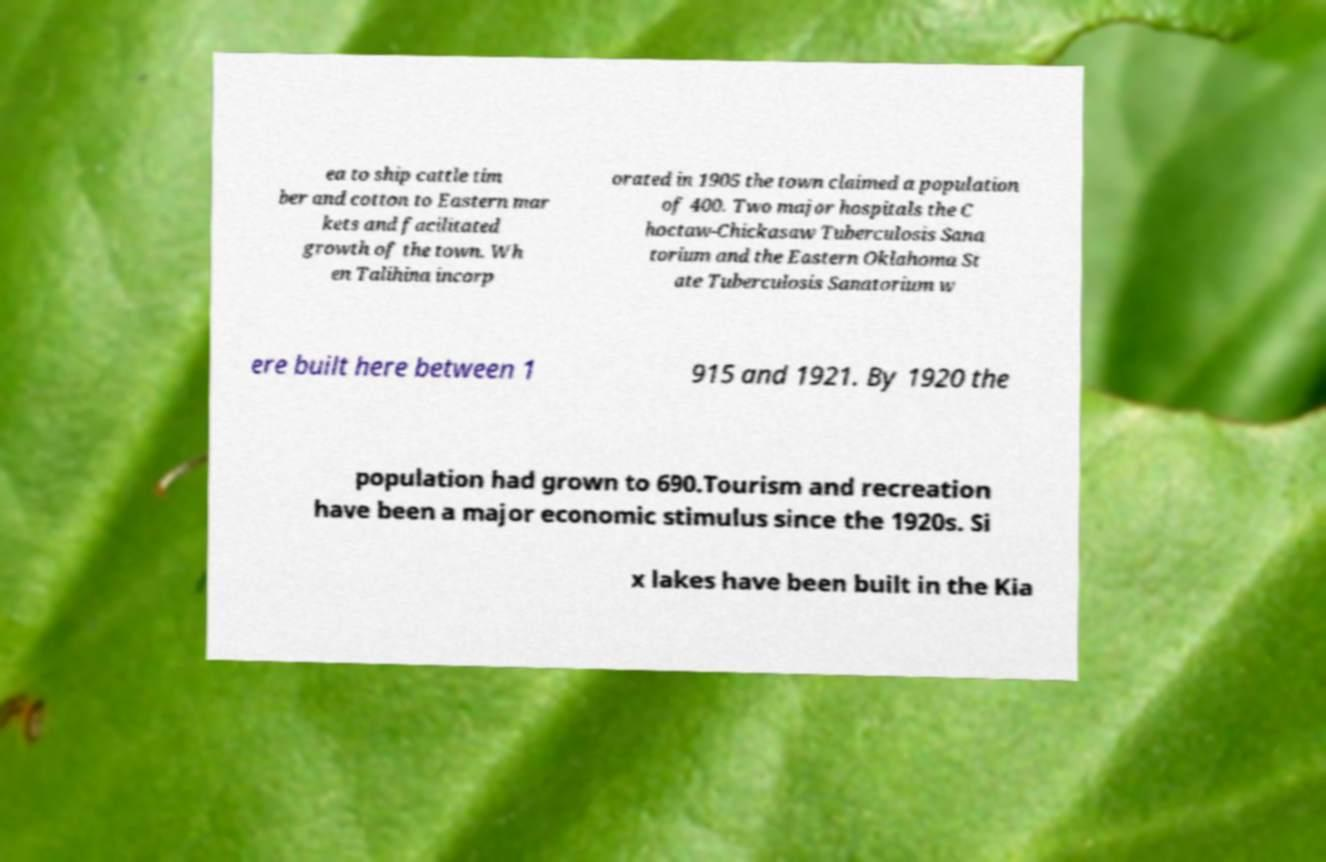Can you accurately transcribe the text from the provided image for me? ea to ship cattle tim ber and cotton to Eastern mar kets and facilitated growth of the town. Wh en Talihina incorp orated in 1905 the town claimed a population of 400. Two major hospitals the C hoctaw-Chickasaw Tuberculosis Sana torium and the Eastern Oklahoma St ate Tuberculosis Sanatorium w ere built here between 1 915 and 1921. By 1920 the population had grown to 690.Tourism and recreation have been a major economic stimulus since the 1920s. Si x lakes have been built in the Kia 